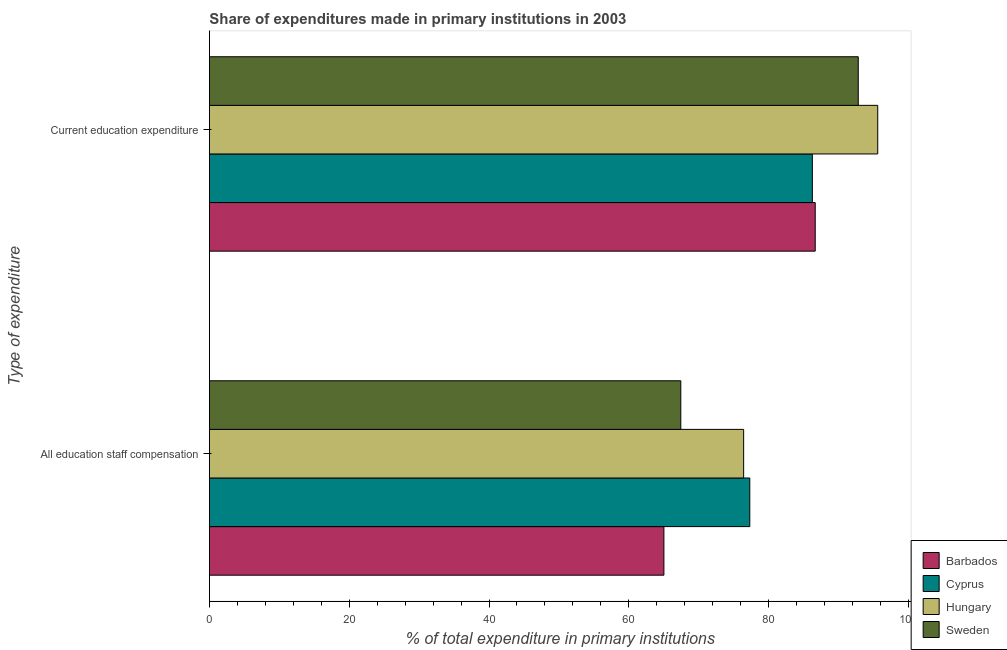How many groups of bars are there?
Provide a short and direct response. 2. What is the label of the 1st group of bars from the top?
Your answer should be compact. Current education expenditure. What is the expenditure in education in Barbados?
Give a very brief answer. 86.66. Across all countries, what is the maximum expenditure in education?
Your answer should be compact. 95.61. Across all countries, what is the minimum expenditure in staff compensation?
Provide a short and direct response. 65.02. In which country was the expenditure in education maximum?
Ensure brevity in your answer.  Hungary. In which country was the expenditure in staff compensation minimum?
Your response must be concise. Barbados. What is the total expenditure in staff compensation in the graph?
Give a very brief answer. 286.18. What is the difference between the expenditure in education in Cyprus and that in Barbados?
Provide a succinct answer. -0.41. What is the difference between the expenditure in staff compensation in Barbados and the expenditure in education in Hungary?
Your response must be concise. -30.59. What is the average expenditure in staff compensation per country?
Your response must be concise. 71.54. What is the difference between the expenditure in education and expenditure in staff compensation in Cyprus?
Provide a short and direct response. 8.95. What is the ratio of the expenditure in education in Cyprus to that in Hungary?
Give a very brief answer. 0.9. Is the expenditure in staff compensation in Cyprus less than that in Barbados?
Your answer should be very brief. No. In how many countries, is the expenditure in education greater than the average expenditure in education taken over all countries?
Your answer should be very brief. 2. What does the 1st bar from the top in Current education expenditure represents?
Make the answer very short. Sweden. What does the 1st bar from the bottom in Current education expenditure represents?
Ensure brevity in your answer.  Barbados. How many bars are there?
Offer a terse response. 8. Are all the bars in the graph horizontal?
Ensure brevity in your answer.  Yes. How many countries are there in the graph?
Your answer should be compact. 4. Are the values on the major ticks of X-axis written in scientific E-notation?
Offer a terse response. No. How many legend labels are there?
Make the answer very short. 4. What is the title of the graph?
Make the answer very short. Share of expenditures made in primary institutions in 2003. Does "Heavily indebted poor countries" appear as one of the legend labels in the graph?
Your response must be concise. No. What is the label or title of the X-axis?
Offer a terse response. % of total expenditure in primary institutions. What is the label or title of the Y-axis?
Provide a succinct answer. Type of expenditure. What is the % of total expenditure in primary institutions of Barbados in All education staff compensation?
Provide a short and direct response. 65.02. What is the % of total expenditure in primary institutions in Cyprus in All education staff compensation?
Your answer should be very brief. 77.3. What is the % of total expenditure in primary institutions in Hungary in All education staff compensation?
Provide a short and direct response. 76.42. What is the % of total expenditure in primary institutions in Sweden in All education staff compensation?
Offer a very short reply. 67.43. What is the % of total expenditure in primary institutions of Barbados in Current education expenditure?
Offer a very short reply. 86.66. What is the % of total expenditure in primary institutions of Cyprus in Current education expenditure?
Provide a succinct answer. 86.25. What is the % of total expenditure in primary institutions in Hungary in Current education expenditure?
Your answer should be very brief. 95.61. What is the % of total expenditure in primary institutions in Sweden in Current education expenditure?
Your answer should be very brief. 92.82. Across all Type of expenditure, what is the maximum % of total expenditure in primary institutions of Barbados?
Offer a terse response. 86.66. Across all Type of expenditure, what is the maximum % of total expenditure in primary institutions of Cyprus?
Give a very brief answer. 86.25. Across all Type of expenditure, what is the maximum % of total expenditure in primary institutions of Hungary?
Your answer should be compact. 95.61. Across all Type of expenditure, what is the maximum % of total expenditure in primary institutions in Sweden?
Make the answer very short. 92.82. Across all Type of expenditure, what is the minimum % of total expenditure in primary institutions in Barbados?
Make the answer very short. 65.02. Across all Type of expenditure, what is the minimum % of total expenditure in primary institutions in Cyprus?
Ensure brevity in your answer.  77.3. Across all Type of expenditure, what is the minimum % of total expenditure in primary institutions of Hungary?
Keep it short and to the point. 76.42. Across all Type of expenditure, what is the minimum % of total expenditure in primary institutions of Sweden?
Offer a terse response. 67.43. What is the total % of total expenditure in primary institutions in Barbados in the graph?
Give a very brief answer. 151.68. What is the total % of total expenditure in primary institutions in Cyprus in the graph?
Ensure brevity in your answer.  163.56. What is the total % of total expenditure in primary institutions of Hungary in the graph?
Provide a succinct answer. 172.03. What is the total % of total expenditure in primary institutions of Sweden in the graph?
Ensure brevity in your answer.  160.26. What is the difference between the % of total expenditure in primary institutions in Barbados in All education staff compensation and that in Current education expenditure?
Your answer should be compact. -21.65. What is the difference between the % of total expenditure in primary institutions in Cyprus in All education staff compensation and that in Current education expenditure?
Your answer should be very brief. -8.95. What is the difference between the % of total expenditure in primary institutions in Hungary in All education staff compensation and that in Current education expenditure?
Your answer should be compact. -19.18. What is the difference between the % of total expenditure in primary institutions of Sweden in All education staff compensation and that in Current education expenditure?
Your answer should be compact. -25.39. What is the difference between the % of total expenditure in primary institutions in Barbados in All education staff compensation and the % of total expenditure in primary institutions in Cyprus in Current education expenditure?
Offer a terse response. -21.24. What is the difference between the % of total expenditure in primary institutions in Barbados in All education staff compensation and the % of total expenditure in primary institutions in Hungary in Current education expenditure?
Offer a terse response. -30.59. What is the difference between the % of total expenditure in primary institutions of Barbados in All education staff compensation and the % of total expenditure in primary institutions of Sweden in Current education expenditure?
Your answer should be compact. -27.81. What is the difference between the % of total expenditure in primary institutions in Cyprus in All education staff compensation and the % of total expenditure in primary institutions in Hungary in Current education expenditure?
Ensure brevity in your answer.  -18.3. What is the difference between the % of total expenditure in primary institutions of Cyprus in All education staff compensation and the % of total expenditure in primary institutions of Sweden in Current education expenditure?
Offer a terse response. -15.52. What is the difference between the % of total expenditure in primary institutions of Hungary in All education staff compensation and the % of total expenditure in primary institutions of Sweden in Current education expenditure?
Keep it short and to the point. -16.4. What is the average % of total expenditure in primary institutions in Barbados per Type of expenditure?
Offer a very short reply. 75.84. What is the average % of total expenditure in primary institutions of Cyprus per Type of expenditure?
Provide a succinct answer. 81.78. What is the average % of total expenditure in primary institutions in Hungary per Type of expenditure?
Offer a terse response. 86.02. What is the average % of total expenditure in primary institutions in Sweden per Type of expenditure?
Offer a terse response. 80.13. What is the difference between the % of total expenditure in primary institutions in Barbados and % of total expenditure in primary institutions in Cyprus in All education staff compensation?
Provide a short and direct response. -12.29. What is the difference between the % of total expenditure in primary institutions of Barbados and % of total expenditure in primary institutions of Hungary in All education staff compensation?
Offer a very short reply. -11.41. What is the difference between the % of total expenditure in primary institutions in Barbados and % of total expenditure in primary institutions in Sweden in All education staff compensation?
Provide a succinct answer. -2.42. What is the difference between the % of total expenditure in primary institutions of Cyprus and % of total expenditure in primary institutions of Hungary in All education staff compensation?
Keep it short and to the point. 0.88. What is the difference between the % of total expenditure in primary institutions in Cyprus and % of total expenditure in primary institutions in Sweden in All education staff compensation?
Make the answer very short. 9.87. What is the difference between the % of total expenditure in primary institutions in Hungary and % of total expenditure in primary institutions in Sweden in All education staff compensation?
Give a very brief answer. 8.99. What is the difference between the % of total expenditure in primary institutions of Barbados and % of total expenditure in primary institutions of Cyprus in Current education expenditure?
Offer a terse response. 0.41. What is the difference between the % of total expenditure in primary institutions in Barbados and % of total expenditure in primary institutions in Hungary in Current education expenditure?
Give a very brief answer. -8.94. What is the difference between the % of total expenditure in primary institutions of Barbados and % of total expenditure in primary institutions of Sweden in Current education expenditure?
Ensure brevity in your answer.  -6.16. What is the difference between the % of total expenditure in primary institutions of Cyprus and % of total expenditure in primary institutions of Hungary in Current education expenditure?
Offer a very short reply. -9.35. What is the difference between the % of total expenditure in primary institutions of Cyprus and % of total expenditure in primary institutions of Sweden in Current education expenditure?
Keep it short and to the point. -6.57. What is the difference between the % of total expenditure in primary institutions of Hungary and % of total expenditure in primary institutions of Sweden in Current education expenditure?
Your response must be concise. 2.78. What is the ratio of the % of total expenditure in primary institutions of Barbados in All education staff compensation to that in Current education expenditure?
Provide a succinct answer. 0.75. What is the ratio of the % of total expenditure in primary institutions in Cyprus in All education staff compensation to that in Current education expenditure?
Make the answer very short. 0.9. What is the ratio of the % of total expenditure in primary institutions in Hungary in All education staff compensation to that in Current education expenditure?
Your answer should be compact. 0.8. What is the ratio of the % of total expenditure in primary institutions of Sweden in All education staff compensation to that in Current education expenditure?
Provide a short and direct response. 0.73. What is the difference between the highest and the second highest % of total expenditure in primary institutions in Barbados?
Offer a very short reply. 21.65. What is the difference between the highest and the second highest % of total expenditure in primary institutions in Cyprus?
Make the answer very short. 8.95. What is the difference between the highest and the second highest % of total expenditure in primary institutions of Hungary?
Offer a terse response. 19.18. What is the difference between the highest and the second highest % of total expenditure in primary institutions of Sweden?
Keep it short and to the point. 25.39. What is the difference between the highest and the lowest % of total expenditure in primary institutions in Barbados?
Ensure brevity in your answer.  21.65. What is the difference between the highest and the lowest % of total expenditure in primary institutions in Cyprus?
Your answer should be very brief. 8.95. What is the difference between the highest and the lowest % of total expenditure in primary institutions of Hungary?
Your answer should be very brief. 19.18. What is the difference between the highest and the lowest % of total expenditure in primary institutions in Sweden?
Your response must be concise. 25.39. 